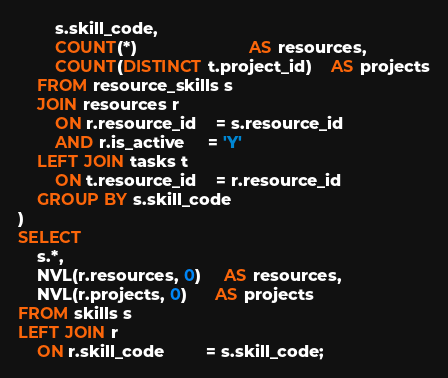Convert code to text. <code><loc_0><loc_0><loc_500><loc_500><_SQL_>        s.skill_code,
        COUNT(*)                        AS resources,
        COUNT(DISTINCT t.project_id)    AS projects
    FROM resource_skills s
    JOIN resources r
        ON r.resource_id    = s.resource_id
        AND r.is_active     = 'Y'
    LEFT JOIN tasks t
        ON t.resource_id    = r.resource_id
    GROUP BY s.skill_code
)
SELECT
    s.*,
    NVL(r.resources, 0)     AS resources,
    NVL(r.projects, 0)      AS projects
FROM skills s
LEFT JOIN r
    ON r.skill_code         = s.skill_code;

</code> 